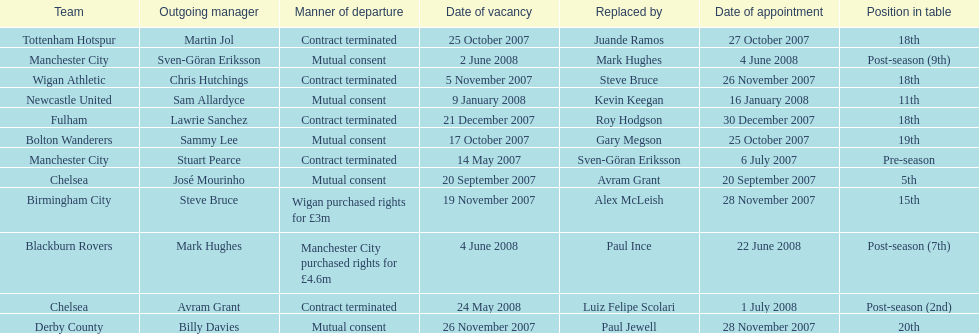Avram grant was with chelsea for at least how many years? 1. Could you parse the entire table? {'header': ['Team', 'Outgoing manager', 'Manner of departure', 'Date of vacancy', 'Replaced by', 'Date of appointment', 'Position in table'], 'rows': [['Tottenham Hotspur', 'Martin Jol', 'Contract terminated', '25 October 2007', 'Juande Ramos', '27 October 2007', '18th'], ['Manchester City', 'Sven-Göran Eriksson', 'Mutual consent', '2 June 2008', 'Mark Hughes', '4 June 2008', 'Post-season (9th)'], ['Wigan Athletic', 'Chris Hutchings', 'Contract terminated', '5 November 2007', 'Steve Bruce', '26 November 2007', '18th'], ['Newcastle United', 'Sam Allardyce', 'Mutual consent', '9 January 2008', 'Kevin Keegan', '16 January 2008', '11th'], ['Fulham', 'Lawrie Sanchez', 'Contract terminated', '21 December 2007', 'Roy Hodgson', '30 December 2007', '18th'], ['Bolton Wanderers', 'Sammy Lee', 'Mutual consent', '17 October 2007', 'Gary Megson', '25 October 2007', '19th'], ['Manchester City', 'Stuart Pearce', 'Contract terminated', '14 May 2007', 'Sven-Göran Eriksson', '6 July 2007', 'Pre-season'], ['Chelsea', 'José Mourinho', 'Mutual consent', '20 September 2007', 'Avram Grant', '20 September 2007', '5th'], ['Birmingham City', 'Steve Bruce', 'Wigan purchased rights for £3m', '19 November 2007', 'Alex McLeish', '28 November 2007', '15th'], ['Blackburn Rovers', 'Mark Hughes', 'Manchester City purchased rights for £4.6m', '4 June 2008', 'Paul Ince', '22 June 2008', 'Post-season (7th)'], ['Chelsea', 'Avram Grant', 'Contract terminated', '24 May 2008', 'Luiz Felipe Scolari', '1 July 2008', 'Post-season (2nd)'], ['Derby County', 'Billy Davies', 'Mutual consent', '26 November 2007', 'Paul Jewell', '28 November 2007', '20th']]} 